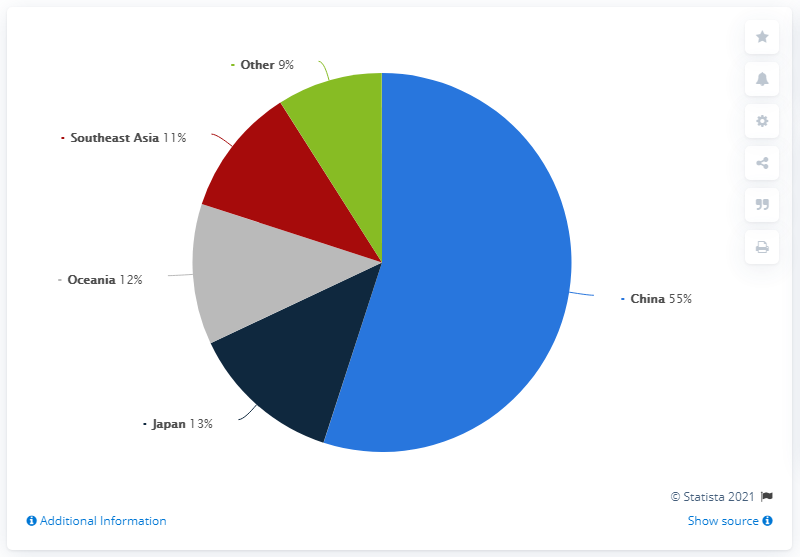What does the sales distribution tell us about the economic influence of China in this region? The sales distribution indicates that China holds a predominant economic influence in the region, commanding more than half of the total market share at 55%. This dominance reflects China's substantial role in regional economics, likely driven by its large population and robust economy. 